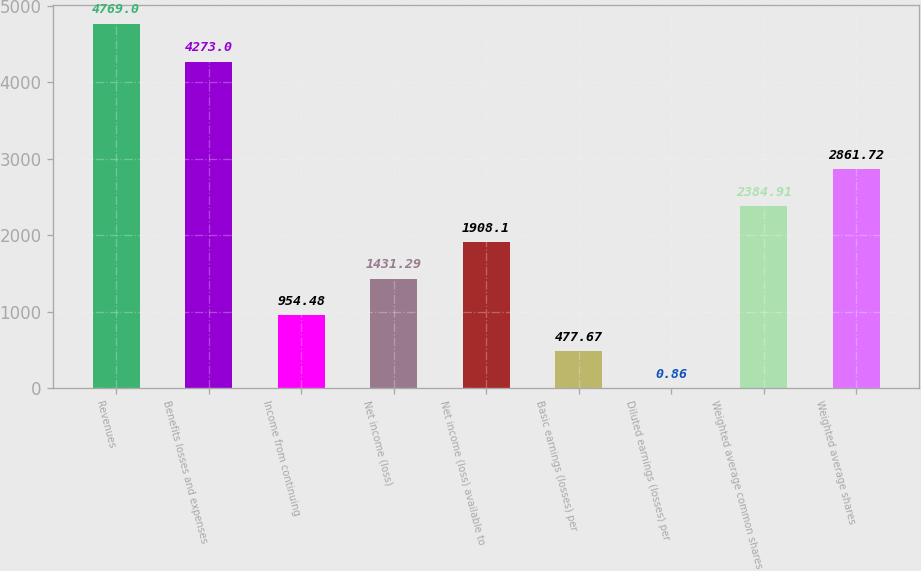Convert chart to OTSL. <chart><loc_0><loc_0><loc_500><loc_500><bar_chart><fcel>Revenues<fcel>Benefits losses and expenses<fcel>Income from continuing<fcel>Net income (loss)<fcel>Net income (loss) available to<fcel>Basic earnings (losses) per<fcel>Diluted earnings (losses) per<fcel>Weighted average common shares<fcel>Weighted average shares<nl><fcel>4769<fcel>4273<fcel>954.48<fcel>1431.29<fcel>1908.1<fcel>477.67<fcel>0.86<fcel>2384.91<fcel>2861.72<nl></chart> 